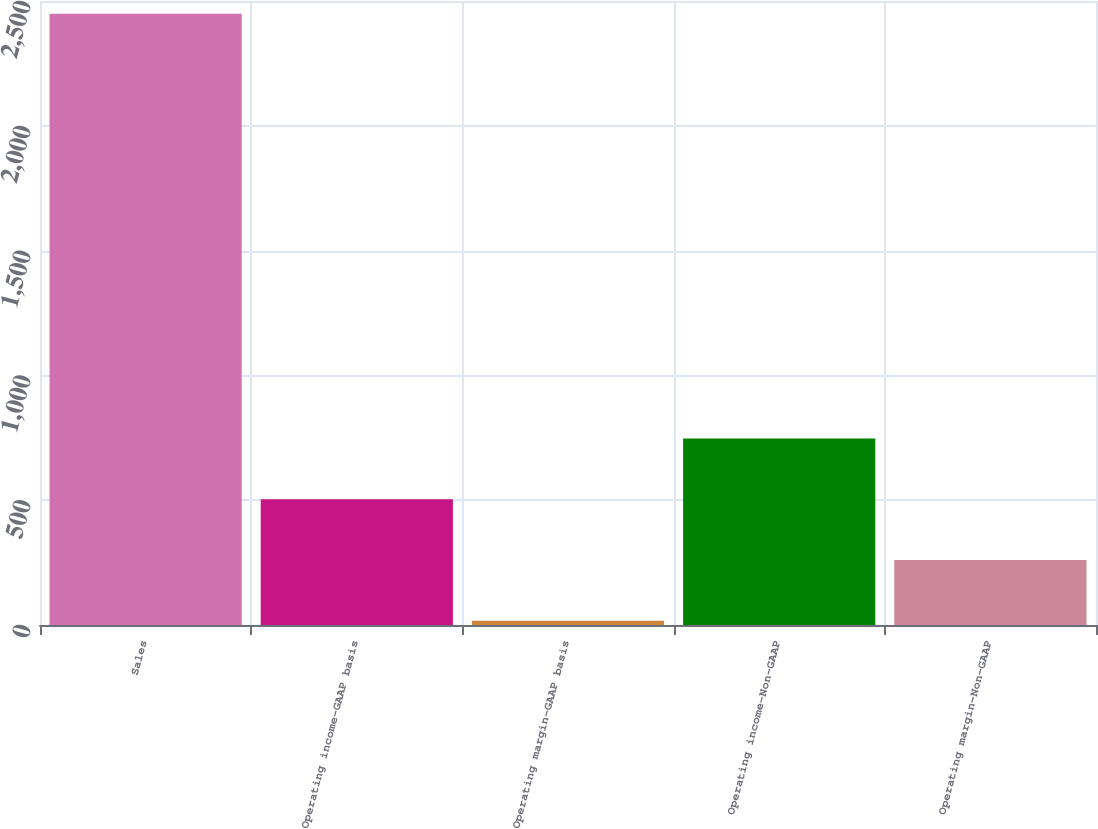Convert chart to OTSL. <chart><loc_0><loc_0><loc_500><loc_500><bar_chart><fcel>Sales<fcel>Operating income-GAAP basis<fcel>Operating margin-GAAP basis<fcel>Operating income-Non-GAAP<fcel>Operating margin-Non-GAAP<nl><fcel>2449<fcel>503.72<fcel>17.4<fcel>746.88<fcel>260.56<nl></chart> 